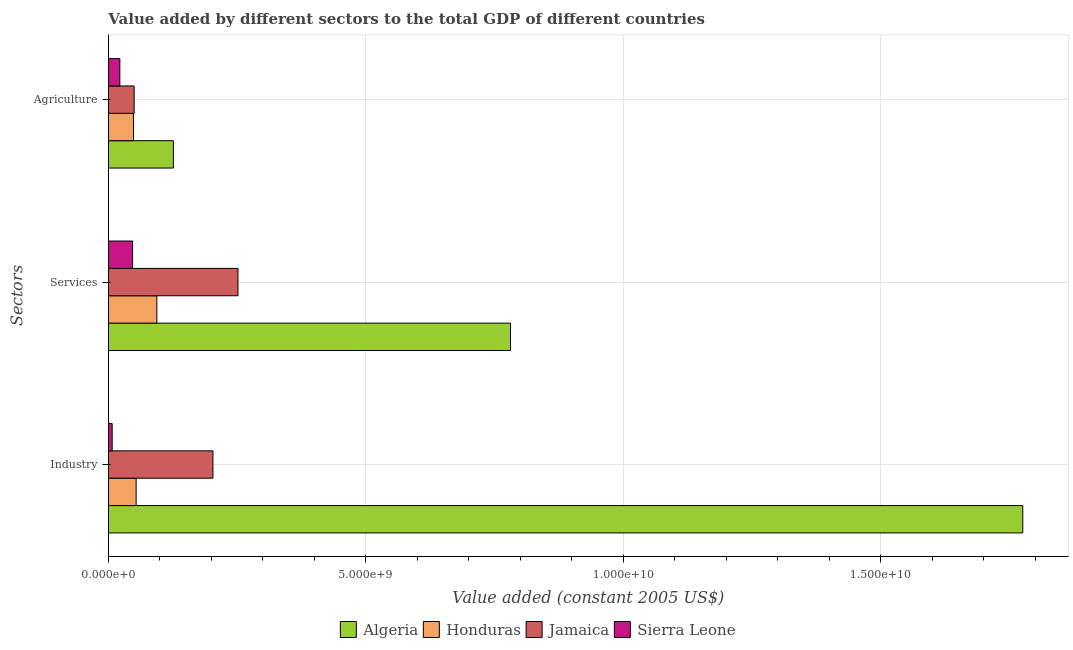Are the number of bars per tick equal to the number of legend labels?
Offer a very short reply. Yes. How many bars are there on the 3rd tick from the bottom?
Keep it short and to the point. 4. What is the label of the 1st group of bars from the top?
Keep it short and to the point. Agriculture. What is the value added by industrial sector in Jamaica?
Your answer should be very brief. 2.03e+09. Across all countries, what is the maximum value added by industrial sector?
Offer a terse response. 1.78e+1. Across all countries, what is the minimum value added by services?
Offer a terse response. 4.69e+08. In which country was the value added by agricultural sector maximum?
Offer a terse response. Algeria. In which country was the value added by services minimum?
Ensure brevity in your answer.  Sierra Leone. What is the total value added by agricultural sector in the graph?
Provide a short and direct response. 2.47e+09. What is the difference between the value added by agricultural sector in Jamaica and that in Sierra Leone?
Provide a succinct answer. 2.77e+08. What is the difference between the value added by services in Sierra Leone and the value added by industrial sector in Algeria?
Provide a short and direct response. -1.73e+1. What is the average value added by services per country?
Offer a terse response. 2.93e+09. What is the difference between the value added by services and value added by industrial sector in Jamaica?
Keep it short and to the point. 4.86e+08. In how many countries, is the value added by industrial sector greater than 17000000000 US$?
Your response must be concise. 1. What is the ratio of the value added by industrial sector in Jamaica to that in Algeria?
Provide a succinct answer. 0.11. Is the value added by agricultural sector in Sierra Leone less than that in Jamaica?
Offer a very short reply. Yes. Is the difference between the value added by agricultural sector in Jamaica and Sierra Leone greater than the difference between the value added by industrial sector in Jamaica and Sierra Leone?
Offer a terse response. No. What is the difference between the highest and the second highest value added by agricultural sector?
Offer a very short reply. 7.62e+08. What is the difference between the highest and the lowest value added by industrial sector?
Make the answer very short. 1.77e+1. In how many countries, is the value added by services greater than the average value added by services taken over all countries?
Give a very brief answer. 1. Is the sum of the value added by agricultural sector in Algeria and Honduras greater than the maximum value added by services across all countries?
Your response must be concise. No. What does the 2nd bar from the top in Agriculture represents?
Make the answer very short. Jamaica. What does the 2nd bar from the bottom in Services represents?
Offer a terse response. Honduras. Is it the case that in every country, the sum of the value added by industrial sector and value added by services is greater than the value added by agricultural sector?
Keep it short and to the point. Yes. Are all the bars in the graph horizontal?
Offer a very short reply. Yes. How many countries are there in the graph?
Offer a terse response. 4. How are the legend labels stacked?
Keep it short and to the point. Horizontal. What is the title of the graph?
Your response must be concise. Value added by different sectors to the total GDP of different countries. Does "Marshall Islands" appear as one of the legend labels in the graph?
Make the answer very short. No. What is the label or title of the X-axis?
Offer a very short reply. Value added (constant 2005 US$). What is the label or title of the Y-axis?
Offer a terse response. Sectors. What is the Value added (constant 2005 US$) in Algeria in Industry?
Your answer should be compact. 1.78e+1. What is the Value added (constant 2005 US$) of Honduras in Industry?
Offer a terse response. 5.38e+08. What is the Value added (constant 2005 US$) of Jamaica in Industry?
Your answer should be very brief. 2.03e+09. What is the Value added (constant 2005 US$) in Sierra Leone in Industry?
Provide a succinct answer. 7.28e+07. What is the Value added (constant 2005 US$) of Algeria in Services?
Give a very brief answer. 7.81e+09. What is the Value added (constant 2005 US$) of Honduras in Services?
Your answer should be very brief. 9.40e+08. What is the Value added (constant 2005 US$) of Jamaica in Services?
Your answer should be very brief. 2.52e+09. What is the Value added (constant 2005 US$) of Sierra Leone in Services?
Your response must be concise. 4.69e+08. What is the Value added (constant 2005 US$) of Algeria in Agriculture?
Offer a terse response. 1.26e+09. What is the Value added (constant 2005 US$) in Honduras in Agriculture?
Provide a succinct answer. 4.88e+08. What is the Value added (constant 2005 US$) of Jamaica in Agriculture?
Your answer should be compact. 4.99e+08. What is the Value added (constant 2005 US$) of Sierra Leone in Agriculture?
Provide a succinct answer. 2.22e+08. Across all Sectors, what is the maximum Value added (constant 2005 US$) of Algeria?
Provide a succinct answer. 1.78e+1. Across all Sectors, what is the maximum Value added (constant 2005 US$) of Honduras?
Offer a very short reply. 9.40e+08. Across all Sectors, what is the maximum Value added (constant 2005 US$) in Jamaica?
Your response must be concise. 2.52e+09. Across all Sectors, what is the maximum Value added (constant 2005 US$) of Sierra Leone?
Provide a short and direct response. 4.69e+08. Across all Sectors, what is the minimum Value added (constant 2005 US$) of Algeria?
Ensure brevity in your answer.  1.26e+09. Across all Sectors, what is the minimum Value added (constant 2005 US$) in Honduras?
Keep it short and to the point. 4.88e+08. Across all Sectors, what is the minimum Value added (constant 2005 US$) in Jamaica?
Your response must be concise. 4.99e+08. Across all Sectors, what is the minimum Value added (constant 2005 US$) of Sierra Leone?
Keep it short and to the point. 7.28e+07. What is the total Value added (constant 2005 US$) in Algeria in the graph?
Offer a very short reply. 2.68e+1. What is the total Value added (constant 2005 US$) in Honduras in the graph?
Offer a terse response. 1.97e+09. What is the total Value added (constant 2005 US$) of Jamaica in the graph?
Your response must be concise. 5.04e+09. What is the total Value added (constant 2005 US$) of Sierra Leone in the graph?
Your answer should be very brief. 7.63e+08. What is the difference between the Value added (constant 2005 US$) of Algeria in Industry and that in Services?
Give a very brief answer. 9.95e+09. What is the difference between the Value added (constant 2005 US$) of Honduras in Industry and that in Services?
Give a very brief answer. -4.02e+08. What is the difference between the Value added (constant 2005 US$) of Jamaica in Industry and that in Services?
Provide a short and direct response. -4.86e+08. What is the difference between the Value added (constant 2005 US$) in Sierra Leone in Industry and that in Services?
Offer a very short reply. -3.96e+08. What is the difference between the Value added (constant 2005 US$) of Algeria in Industry and that in Agriculture?
Offer a very short reply. 1.65e+1. What is the difference between the Value added (constant 2005 US$) in Honduras in Industry and that in Agriculture?
Ensure brevity in your answer.  5.02e+07. What is the difference between the Value added (constant 2005 US$) of Jamaica in Industry and that in Agriculture?
Make the answer very short. 1.53e+09. What is the difference between the Value added (constant 2005 US$) of Sierra Leone in Industry and that in Agriculture?
Offer a very short reply. -1.49e+08. What is the difference between the Value added (constant 2005 US$) in Algeria in Services and that in Agriculture?
Make the answer very short. 6.55e+09. What is the difference between the Value added (constant 2005 US$) of Honduras in Services and that in Agriculture?
Your answer should be very brief. 4.52e+08. What is the difference between the Value added (constant 2005 US$) of Jamaica in Services and that in Agriculture?
Provide a short and direct response. 2.02e+09. What is the difference between the Value added (constant 2005 US$) in Sierra Leone in Services and that in Agriculture?
Provide a succinct answer. 2.48e+08. What is the difference between the Value added (constant 2005 US$) in Algeria in Industry and the Value added (constant 2005 US$) in Honduras in Services?
Ensure brevity in your answer.  1.68e+1. What is the difference between the Value added (constant 2005 US$) in Algeria in Industry and the Value added (constant 2005 US$) in Jamaica in Services?
Your answer should be very brief. 1.52e+1. What is the difference between the Value added (constant 2005 US$) of Algeria in Industry and the Value added (constant 2005 US$) of Sierra Leone in Services?
Your response must be concise. 1.73e+1. What is the difference between the Value added (constant 2005 US$) of Honduras in Industry and the Value added (constant 2005 US$) of Jamaica in Services?
Provide a short and direct response. -1.98e+09. What is the difference between the Value added (constant 2005 US$) in Honduras in Industry and the Value added (constant 2005 US$) in Sierra Leone in Services?
Provide a short and direct response. 6.88e+07. What is the difference between the Value added (constant 2005 US$) in Jamaica in Industry and the Value added (constant 2005 US$) in Sierra Leone in Services?
Make the answer very short. 1.56e+09. What is the difference between the Value added (constant 2005 US$) in Algeria in Industry and the Value added (constant 2005 US$) in Honduras in Agriculture?
Give a very brief answer. 1.73e+1. What is the difference between the Value added (constant 2005 US$) in Algeria in Industry and the Value added (constant 2005 US$) in Jamaica in Agriculture?
Keep it short and to the point. 1.73e+1. What is the difference between the Value added (constant 2005 US$) of Algeria in Industry and the Value added (constant 2005 US$) of Sierra Leone in Agriculture?
Provide a succinct answer. 1.75e+1. What is the difference between the Value added (constant 2005 US$) of Honduras in Industry and the Value added (constant 2005 US$) of Jamaica in Agriculture?
Your response must be concise. 3.90e+07. What is the difference between the Value added (constant 2005 US$) in Honduras in Industry and the Value added (constant 2005 US$) in Sierra Leone in Agriculture?
Your answer should be compact. 3.16e+08. What is the difference between the Value added (constant 2005 US$) in Jamaica in Industry and the Value added (constant 2005 US$) in Sierra Leone in Agriculture?
Your response must be concise. 1.81e+09. What is the difference between the Value added (constant 2005 US$) in Algeria in Services and the Value added (constant 2005 US$) in Honduras in Agriculture?
Your response must be concise. 7.32e+09. What is the difference between the Value added (constant 2005 US$) of Algeria in Services and the Value added (constant 2005 US$) of Jamaica in Agriculture?
Your answer should be very brief. 7.31e+09. What is the difference between the Value added (constant 2005 US$) in Algeria in Services and the Value added (constant 2005 US$) in Sierra Leone in Agriculture?
Keep it short and to the point. 7.59e+09. What is the difference between the Value added (constant 2005 US$) in Honduras in Services and the Value added (constant 2005 US$) in Jamaica in Agriculture?
Offer a very short reply. 4.41e+08. What is the difference between the Value added (constant 2005 US$) of Honduras in Services and the Value added (constant 2005 US$) of Sierra Leone in Agriculture?
Provide a succinct answer. 7.19e+08. What is the difference between the Value added (constant 2005 US$) in Jamaica in Services and the Value added (constant 2005 US$) in Sierra Leone in Agriculture?
Offer a terse response. 2.29e+09. What is the average Value added (constant 2005 US$) in Algeria per Sectors?
Provide a succinct answer. 8.94e+09. What is the average Value added (constant 2005 US$) in Honduras per Sectors?
Give a very brief answer. 6.55e+08. What is the average Value added (constant 2005 US$) of Jamaica per Sectors?
Ensure brevity in your answer.  1.68e+09. What is the average Value added (constant 2005 US$) in Sierra Leone per Sectors?
Provide a short and direct response. 2.54e+08. What is the difference between the Value added (constant 2005 US$) of Algeria and Value added (constant 2005 US$) of Honduras in Industry?
Provide a short and direct response. 1.72e+1. What is the difference between the Value added (constant 2005 US$) in Algeria and Value added (constant 2005 US$) in Jamaica in Industry?
Provide a short and direct response. 1.57e+1. What is the difference between the Value added (constant 2005 US$) in Algeria and Value added (constant 2005 US$) in Sierra Leone in Industry?
Make the answer very short. 1.77e+1. What is the difference between the Value added (constant 2005 US$) of Honduras and Value added (constant 2005 US$) of Jamaica in Industry?
Keep it short and to the point. -1.49e+09. What is the difference between the Value added (constant 2005 US$) of Honduras and Value added (constant 2005 US$) of Sierra Leone in Industry?
Your response must be concise. 4.65e+08. What is the difference between the Value added (constant 2005 US$) in Jamaica and Value added (constant 2005 US$) in Sierra Leone in Industry?
Make the answer very short. 1.96e+09. What is the difference between the Value added (constant 2005 US$) of Algeria and Value added (constant 2005 US$) of Honduras in Services?
Offer a terse response. 6.87e+09. What is the difference between the Value added (constant 2005 US$) of Algeria and Value added (constant 2005 US$) of Jamaica in Services?
Offer a terse response. 5.29e+09. What is the difference between the Value added (constant 2005 US$) of Algeria and Value added (constant 2005 US$) of Sierra Leone in Services?
Offer a very short reply. 7.34e+09. What is the difference between the Value added (constant 2005 US$) in Honduras and Value added (constant 2005 US$) in Jamaica in Services?
Your response must be concise. -1.58e+09. What is the difference between the Value added (constant 2005 US$) in Honduras and Value added (constant 2005 US$) in Sierra Leone in Services?
Your answer should be compact. 4.71e+08. What is the difference between the Value added (constant 2005 US$) of Jamaica and Value added (constant 2005 US$) of Sierra Leone in Services?
Provide a short and direct response. 2.05e+09. What is the difference between the Value added (constant 2005 US$) in Algeria and Value added (constant 2005 US$) in Honduras in Agriculture?
Offer a terse response. 7.73e+08. What is the difference between the Value added (constant 2005 US$) of Algeria and Value added (constant 2005 US$) of Jamaica in Agriculture?
Give a very brief answer. 7.62e+08. What is the difference between the Value added (constant 2005 US$) of Algeria and Value added (constant 2005 US$) of Sierra Leone in Agriculture?
Provide a succinct answer. 1.04e+09. What is the difference between the Value added (constant 2005 US$) in Honduras and Value added (constant 2005 US$) in Jamaica in Agriculture?
Ensure brevity in your answer.  -1.11e+07. What is the difference between the Value added (constant 2005 US$) in Honduras and Value added (constant 2005 US$) in Sierra Leone in Agriculture?
Your answer should be compact. 2.66e+08. What is the difference between the Value added (constant 2005 US$) in Jamaica and Value added (constant 2005 US$) in Sierra Leone in Agriculture?
Make the answer very short. 2.77e+08. What is the ratio of the Value added (constant 2005 US$) in Algeria in Industry to that in Services?
Your response must be concise. 2.27. What is the ratio of the Value added (constant 2005 US$) of Honduras in Industry to that in Services?
Keep it short and to the point. 0.57. What is the ratio of the Value added (constant 2005 US$) in Jamaica in Industry to that in Services?
Keep it short and to the point. 0.81. What is the ratio of the Value added (constant 2005 US$) of Sierra Leone in Industry to that in Services?
Provide a short and direct response. 0.16. What is the ratio of the Value added (constant 2005 US$) of Algeria in Industry to that in Agriculture?
Your answer should be compact. 14.08. What is the ratio of the Value added (constant 2005 US$) in Honduras in Industry to that in Agriculture?
Your answer should be very brief. 1.1. What is the ratio of the Value added (constant 2005 US$) of Jamaica in Industry to that in Agriculture?
Give a very brief answer. 4.07. What is the ratio of the Value added (constant 2005 US$) of Sierra Leone in Industry to that in Agriculture?
Keep it short and to the point. 0.33. What is the ratio of the Value added (constant 2005 US$) in Algeria in Services to that in Agriculture?
Provide a short and direct response. 6.19. What is the ratio of the Value added (constant 2005 US$) of Honduras in Services to that in Agriculture?
Keep it short and to the point. 1.93. What is the ratio of the Value added (constant 2005 US$) of Jamaica in Services to that in Agriculture?
Keep it short and to the point. 5.04. What is the ratio of the Value added (constant 2005 US$) in Sierra Leone in Services to that in Agriculture?
Ensure brevity in your answer.  2.12. What is the difference between the highest and the second highest Value added (constant 2005 US$) of Algeria?
Offer a very short reply. 9.95e+09. What is the difference between the highest and the second highest Value added (constant 2005 US$) of Honduras?
Offer a terse response. 4.02e+08. What is the difference between the highest and the second highest Value added (constant 2005 US$) in Jamaica?
Offer a very short reply. 4.86e+08. What is the difference between the highest and the second highest Value added (constant 2005 US$) of Sierra Leone?
Offer a terse response. 2.48e+08. What is the difference between the highest and the lowest Value added (constant 2005 US$) of Algeria?
Provide a short and direct response. 1.65e+1. What is the difference between the highest and the lowest Value added (constant 2005 US$) in Honduras?
Keep it short and to the point. 4.52e+08. What is the difference between the highest and the lowest Value added (constant 2005 US$) in Jamaica?
Provide a succinct answer. 2.02e+09. What is the difference between the highest and the lowest Value added (constant 2005 US$) in Sierra Leone?
Ensure brevity in your answer.  3.96e+08. 